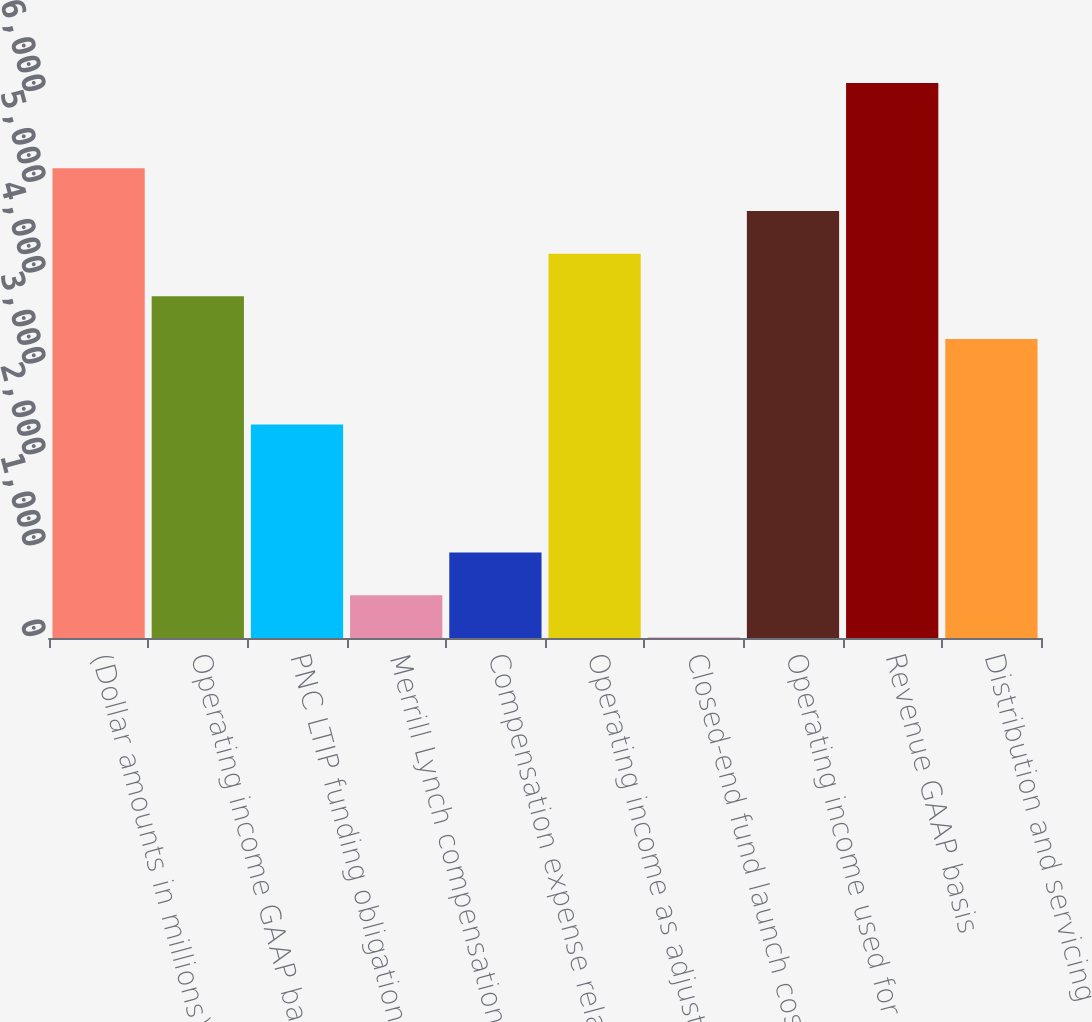<chart> <loc_0><loc_0><loc_500><loc_500><bar_chart><fcel>(Dollar amounts in millions)<fcel>Operating income GAAP basis<fcel>PNC LTIP funding obligation<fcel>Merrill Lynch compensation<fcel>Compensation expense related<fcel>Operating income as adjusted<fcel>Closed-end fund launch costs<fcel>Operating income used for<fcel>Revenue GAAP basis<fcel>Distribution and servicing<nl><fcel>5169.8<fcel>3760.4<fcel>2351<fcel>471.8<fcel>941.6<fcel>4230.2<fcel>2<fcel>4700<fcel>6109.4<fcel>3290.6<nl></chart> 